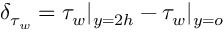<formula> <loc_0><loc_0><loc_500><loc_500>\delta _ { \tau _ { w } } = \tau _ { w } | _ { y = 2 h } - \tau _ { w } | _ { y = o }</formula> 